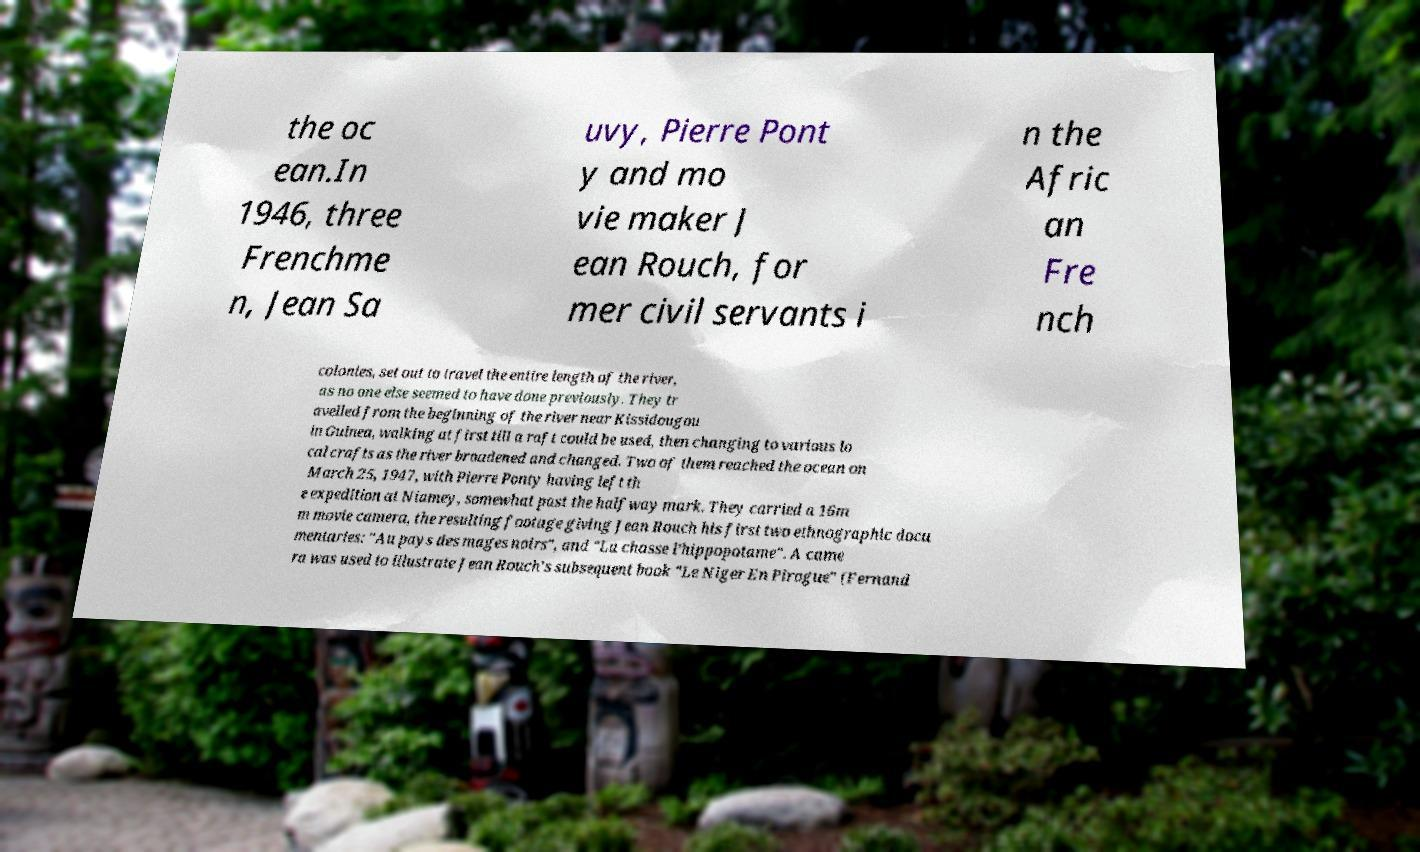I need the written content from this picture converted into text. Can you do that? the oc ean.In 1946, three Frenchme n, Jean Sa uvy, Pierre Pont y and mo vie maker J ean Rouch, for mer civil servants i n the Afric an Fre nch colonies, set out to travel the entire length of the river, as no one else seemed to have done previously. They tr avelled from the beginning of the river near Kissidougou in Guinea, walking at first till a raft could be used, then changing to various lo cal crafts as the river broadened and changed. Two of them reached the ocean on March 25, 1947, with Pierre Ponty having left th e expedition at Niamey, somewhat past the halfway mark. They carried a 16m m movie camera, the resulting footage giving Jean Rouch his first two ethnographic docu mentaries: "Au pays des mages noirs", and "La chasse l’hippopotame". A came ra was used to illustrate Jean Rouch's subsequent book "Le Niger En Pirogue" (Fernand 